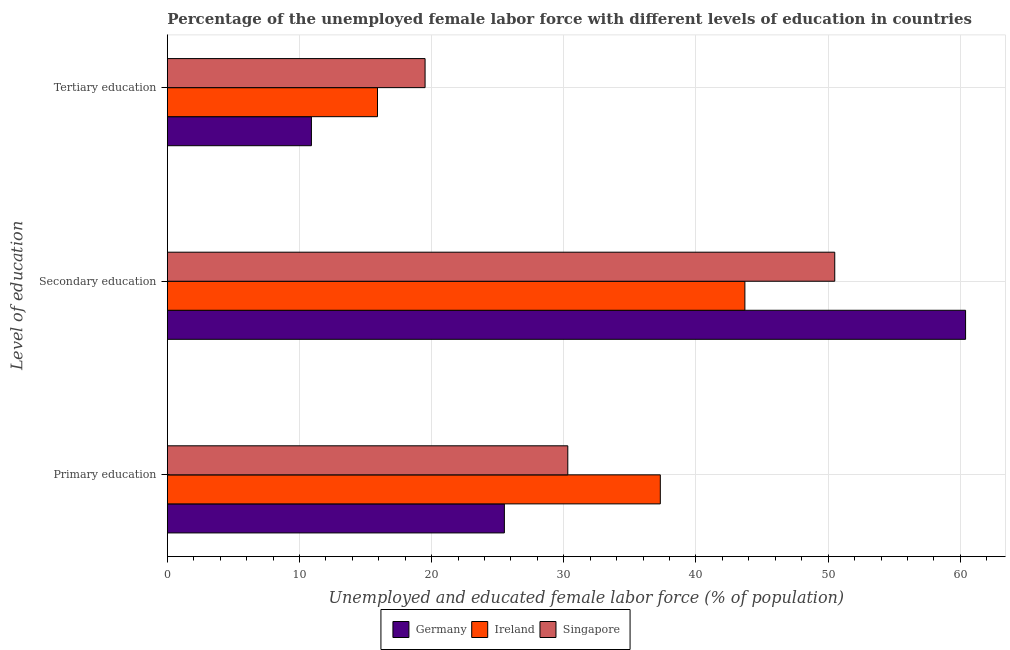How many different coloured bars are there?
Your response must be concise. 3. How many groups of bars are there?
Your response must be concise. 3. Are the number of bars per tick equal to the number of legend labels?
Ensure brevity in your answer.  Yes. How many bars are there on the 2nd tick from the top?
Provide a succinct answer. 3. What is the label of the 2nd group of bars from the top?
Ensure brevity in your answer.  Secondary education. What is the percentage of female labor force who received tertiary education in Germany?
Provide a succinct answer. 10.9. Across all countries, what is the maximum percentage of female labor force who received tertiary education?
Offer a terse response. 19.5. Across all countries, what is the minimum percentage of female labor force who received primary education?
Provide a succinct answer. 25.5. In which country was the percentage of female labor force who received tertiary education maximum?
Keep it short and to the point. Singapore. In which country was the percentage of female labor force who received secondary education minimum?
Provide a succinct answer. Ireland. What is the total percentage of female labor force who received primary education in the graph?
Make the answer very short. 93.1. What is the difference between the percentage of female labor force who received tertiary education in Ireland and that in Germany?
Offer a very short reply. 5. What is the difference between the percentage of female labor force who received primary education in Germany and the percentage of female labor force who received secondary education in Ireland?
Your response must be concise. -18.2. What is the average percentage of female labor force who received secondary education per country?
Ensure brevity in your answer.  51.53. What is the difference between the percentage of female labor force who received primary education and percentage of female labor force who received secondary education in Singapore?
Keep it short and to the point. -20.2. What is the ratio of the percentage of female labor force who received tertiary education in Ireland to that in Germany?
Offer a very short reply. 1.46. What is the difference between the highest and the second highest percentage of female labor force who received tertiary education?
Ensure brevity in your answer.  3.6. What is the difference between the highest and the lowest percentage of female labor force who received primary education?
Your answer should be compact. 11.8. In how many countries, is the percentage of female labor force who received primary education greater than the average percentage of female labor force who received primary education taken over all countries?
Ensure brevity in your answer.  1. Is the sum of the percentage of female labor force who received tertiary education in Ireland and Singapore greater than the maximum percentage of female labor force who received primary education across all countries?
Your response must be concise. No. What does the 3rd bar from the top in Primary education represents?
Ensure brevity in your answer.  Germany. What does the 3rd bar from the bottom in Tertiary education represents?
Give a very brief answer. Singapore. Is it the case that in every country, the sum of the percentage of female labor force who received primary education and percentage of female labor force who received secondary education is greater than the percentage of female labor force who received tertiary education?
Give a very brief answer. Yes. Are all the bars in the graph horizontal?
Make the answer very short. Yes. How many countries are there in the graph?
Make the answer very short. 3. Does the graph contain grids?
Make the answer very short. Yes. Where does the legend appear in the graph?
Ensure brevity in your answer.  Bottom center. What is the title of the graph?
Your answer should be compact. Percentage of the unemployed female labor force with different levels of education in countries. What is the label or title of the X-axis?
Your answer should be compact. Unemployed and educated female labor force (% of population). What is the label or title of the Y-axis?
Ensure brevity in your answer.  Level of education. What is the Unemployed and educated female labor force (% of population) in Ireland in Primary education?
Your answer should be compact. 37.3. What is the Unemployed and educated female labor force (% of population) in Singapore in Primary education?
Your answer should be very brief. 30.3. What is the Unemployed and educated female labor force (% of population) in Germany in Secondary education?
Give a very brief answer. 60.4. What is the Unemployed and educated female labor force (% of population) in Ireland in Secondary education?
Provide a short and direct response. 43.7. What is the Unemployed and educated female labor force (% of population) in Singapore in Secondary education?
Offer a terse response. 50.5. What is the Unemployed and educated female labor force (% of population) in Germany in Tertiary education?
Ensure brevity in your answer.  10.9. What is the Unemployed and educated female labor force (% of population) of Ireland in Tertiary education?
Keep it short and to the point. 15.9. Across all Level of education, what is the maximum Unemployed and educated female labor force (% of population) of Germany?
Your answer should be very brief. 60.4. Across all Level of education, what is the maximum Unemployed and educated female labor force (% of population) in Ireland?
Give a very brief answer. 43.7. Across all Level of education, what is the maximum Unemployed and educated female labor force (% of population) in Singapore?
Your answer should be compact. 50.5. Across all Level of education, what is the minimum Unemployed and educated female labor force (% of population) of Germany?
Provide a short and direct response. 10.9. Across all Level of education, what is the minimum Unemployed and educated female labor force (% of population) in Ireland?
Your answer should be very brief. 15.9. Across all Level of education, what is the minimum Unemployed and educated female labor force (% of population) in Singapore?
Offer a terse response. 19.5. What is the total Unemployed and educated female labor force (% of population) in Germany in the graph?
Your response must be concise. 96.8. What is the total Unemployed and educated female labor force (% of population) in Ireland in the graph?
Keep it short and to the point. 96.9. What is the total Unemployed and educated female labor force (% of population) in Singapore in the graph?
Give a very brief answer. 100.3. What is the difference between the Unemployed and educated female labor force (% of population) of Germany in Primary education and that in Secondary education?
Your answer should be compact. -34.9. What is the difference between the Unemployed and educated female labor force (% of population) in Singapore in Primary education and that in Secondary education?
Keep it short and to the point. -20.2. What is the difference between the Unemployed and educated female labor force (% of population) of Ireland in Primary education and that in Tertiary education?
Ensure brevity in your answer.  21.4. What is the difference between the Unemployed and educated female labor force (% of population) in Germany in Secondary education and that in Tertiary education?
Your response must be concise. 49.5. What is the difference between the Unemployed and educated female labor force (% of population) of Ireland in Secondary education and that in Tertiary education?
Keep it short and to the point. 27.8. What is the difference between the Unemployed and educated female labor force (% of population) in Singapore in Secondary education and that in Tertiary education?
Your answer should be compact. 31. What is the difference between the Unemployed and educated female labor force (% of population) of Germany in Primary education and the Unemployed and educated female labor force (% of population) of Ireland in Secondary education?
Offer a terse response. -18.2. What is the difference between the Unemployed and educated female labor force (% of population) of Germany in Primary education and the Unemployed and educated female labor force (% of population) of Singapore in Secondary education?
Provide a succinct answer. -25. What is the difference between the Unemployed and educated female labor force (% of population) in Ireland in Primary education and the Unemployed and educated female labor force (% of population) in Singapore in Secondary education?
Your answer should be compact. -13.2. What is the difference between the Unemployed and educated female labor force (% of population) of Germany in Primary education and the Unemployed and educated female labor force (% of population) of Ireland in Tertiary education?
Offer a very short reply. 9.6. What is the difference between the Unemployed and educated female labor force (% of population) in Germany in Primary education and the Unemployed and educated female labor force (% of population) in Singapore in Tertiary education?
Provide a succinct answer. 6. What is the difference between the Unemployed and educated female labor force (% of population) of Ireland in Primary education and the Unemployed and educated female labor force (% of population) of Singapore in Tertiary education?
Your answer should be very brief. 17.8. What is the difference between the Unemployed and educated female labor force (% of population) of Germany in Secondary education and the Unemployed and educated female labor force (% of population) of Ireland in Tertiary education?
Offer a terse response. 44.5. What is the difference between the Unemployed and educated female labor force (% of population) in Germany in Secondary education and the Unemployed and educated female labor force (% of population) in Singapore in Tertiary education?
Offer a very short reply. 40.9. What is the difference between the Unemployed and educated female labor force (% of population) in Ireland in Secondary education and the Unemployed and educated female labor force (% of population) in Singapore in Tertiary education?
Provide a short and direct response. 24.2. What is the average Unemployed and educated female labor force (% of population) of Germany per Level of education?
Your answer should be compact. 32.27. What is the average Unemployed and educated female labor force (% of population) of Ireland per Level of education?
Your answer should be compact. 32.3. What is the average Unemployed and educated female labor force (% of population) of Singapore per Level of education?
Provide a succinct answer. 33.43. What is the difference between the Unemployed and educated female labor force (% of population) in Germany and Unemployed and educated female labor force (% of population) in Ireland in Primary education?
Make the answer very short. -11.8. What is the difference between the Unemployed and educated female labor force (% of population) of Ireland and Unemployed and educated female labor force (% of population) of Singapore in Primary education?
Make the answer very short. 7. What is the difference between the Unemployed and educated female labor force (% of population) of Germany and Unemployed and educated female labor force (% of population) of Ireland in Secondary education?
Offer a very short reply. 16.7. What is the difference between the Unemployed and educated female labor force (% of population) of Ireland and Unemployed and educated female labor force (% of population) of Singapore in Tertiary education?
Make the answer very short. -3.6. What is the ratio of the Unemployed and educated female labor force (% of population) in Germany in Primary education to that in Secondary education?
Your answer should be compact. 0.42. What is the ratio of the Unemployed and educated female labor force (% of population) of Ireland in Primary education to that in Secondary education?
Keep it short and to the point. 0.85. What is the ratio of the Unemployed and educated female labor force (% of population) of Germany in Primary education to that in Tertiary education?
Offer a terse response. 2.34. What is the ratio of the Unemployed and educated female labor force (% of population) of Ireland in Primary education to that in Tertiary education?
Ensure brevity in your answer.  2.35. What is the ratio of the Unemployed and educated female labor force (% of population) in Singapore in Primary education to that in Tertiary education?
Provide a short and direct response. 1.55. What is the ratio of the Unemployed and educated female labor force (% of population) of Germany in Secondary education to that in Tertiary education?
Offer a very short reply. 5.54. What is the ratio of the Unemployed and educated female labor force (% of population) of Ireland in Secondary education to that in Tertiary education?
Ensure brevity in your answer.  2.75. What is the ratio of the Unemployed and educated female labor force (% of population) of Singapore in Secondary education to that in Tertiary education?
Provide a succinct answer. 2.59. What is the difference between the highest and the second highest Unemployed and educated female labor force (% of population) in Germany?
Provide a succinct answer. 34.9. What is the difference between the highest and the second highest Unemployed and educated female labor force (% of population) in Ireland?
Give a very brief answer. 6.4. What is the difference between the highest and the second highest Unemployed and educated female labor force (% of population) of Singapore?
Ensure brevity in your answer.  20.2. What is the difference between the highest and the lowest Unemployed and educated female labor force (% of population) of Germany?
Provide a short and direct response. 49.5. What is the difference between the highest and the lowest Unemployed and educated female labor force (% of population) of Ireland?
Your response must be concise. 27.8. What is the difference between the highest and the lowest Unemployed and educated female labor force (% of population) in Singapore?
Ensure brevity in your answer.  31. 